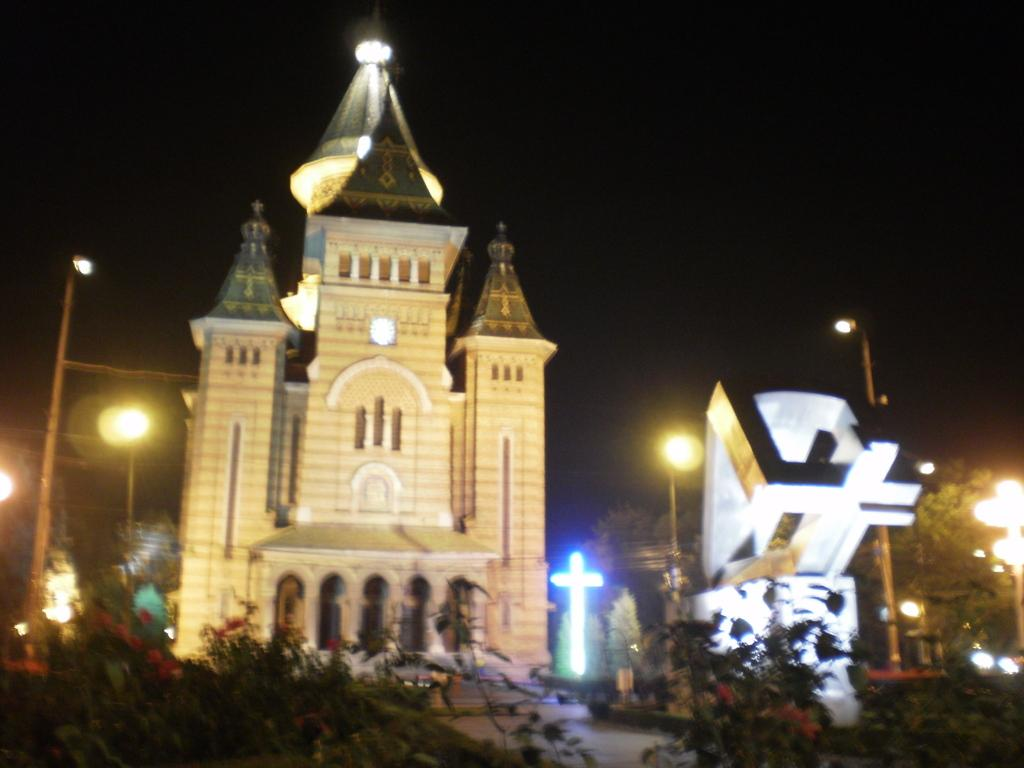What type of natural elements can be seen in the image? There are trees in the image. What man-made structures are present in the image? There are poles, lights, and buildings in the image. How would you describe the overall lighting in the image? The background of the image appears to be darker. What type of punishment is being carried out on the nation in the image? There is no reference to a nation or any form of punishment in the image. How does the nerve system of the trees in the image function? Trees do not have a nerve system; they have a vascular system for transporting nutrients and water. 